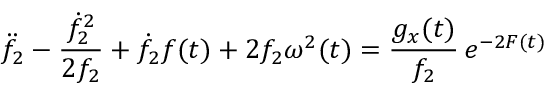Convert formula to latex. <formula><loc_0><loc_0><loc_500><loc_500>\ddot { f } _ { 2 } - \frac { \dot { f } _ { 2 } ^ { 2 } } { 2 f _ { 2 } } + \dot { f } _ { 2 } f ( t ) + 2 f _ { 2 } \omega ^ { 2 } ( t ) = \frac { g _ { x } ( t ) } { f _ { 2 } } \, e ^ { - 2 F ( t ) }</formula> 